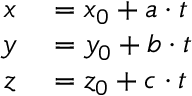Convert formula to latex. <formula><loc_0><loc_0><loc_500><loc_500>\begin{array} { r l } { x } & = x _ { 0 } + a \cdot t } \\ { y } & = y _ { 0 } + b \cdot t } \\ { z } & = z _ { 0 } + c \cdot t } \end{array}</formula> 